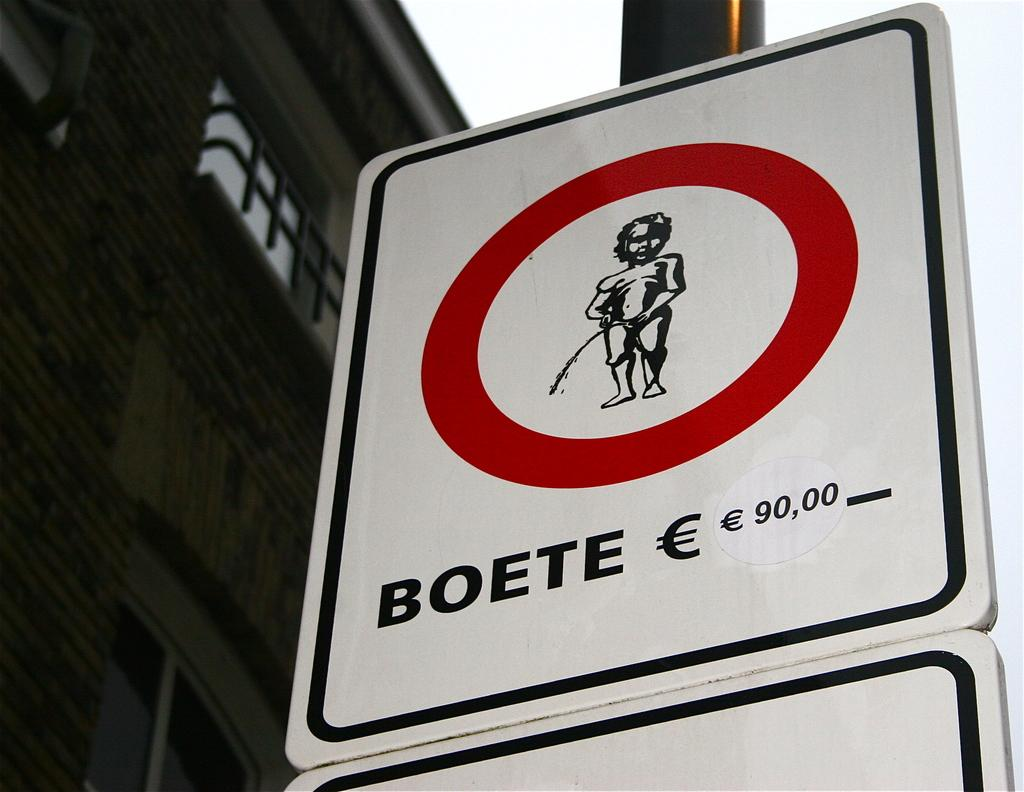<image>
Relay a brief, clear account of the picture shown. a sign with a boy peeing says BOETE 